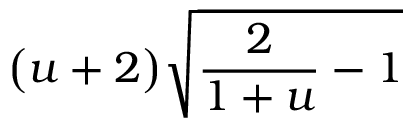Convert formula to latex. <formula><loc_0><loc_0><loc_500><loc_500>\left ( u + 2 \right ) \sqrt { \frac { 2 } { 1 + u } - 1 }</formula> 